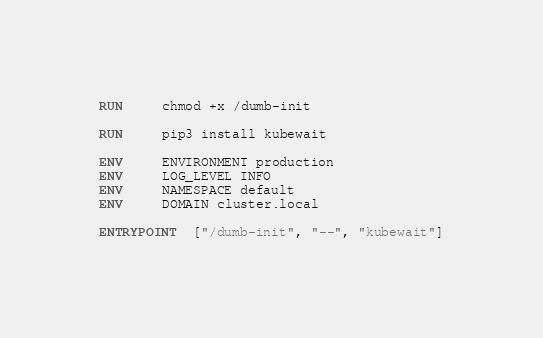<code> <loc_0><loc_0><loc_500><loc_500><_Dockerfile_>RUN     chmod +x /dumb-init

RUN     pip3 install kubewait

ENV     ENVIRONMENT production
ENV     LOG_LEVEL INFO
ENV     NAMESPACE default
ENV     DOMAIN cluster.local

ENTRYPOINT  ["/dumb-init", "--", "kubewait"]
</code> 